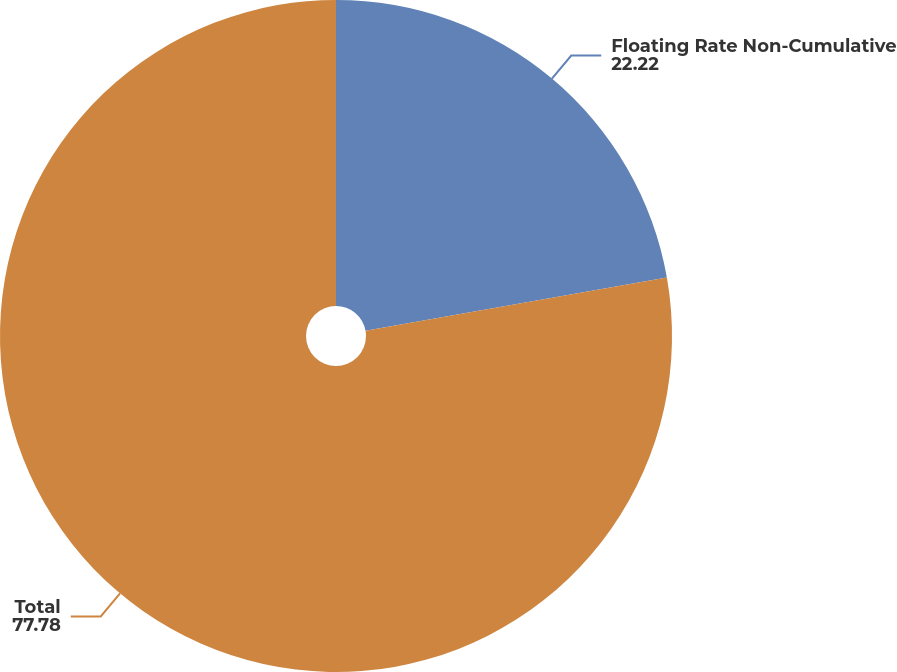Convert chart. <chart><loc_0><loc_0><loc_500><loc_500><pie_chart><fcel>Floating Rate Non-Cumulative<fcel>Total<nl><fcel>22.22%<fcel>77.78%<nl></chart> 